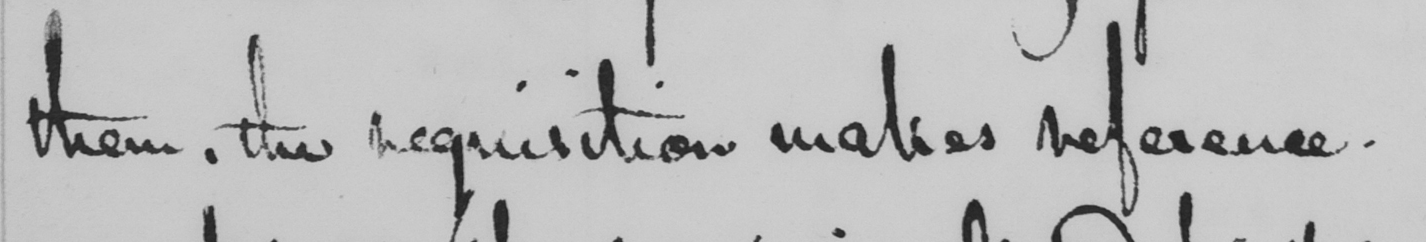What does this handwritten line say? them , the requisition makes reference . 